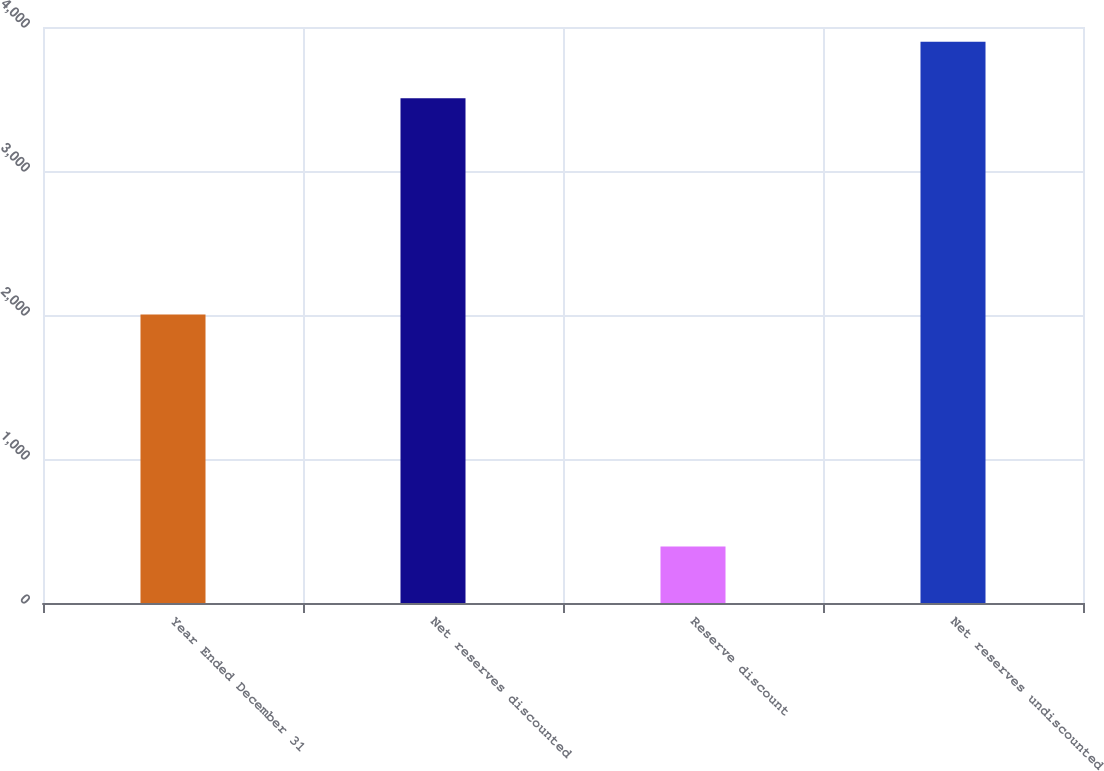Convert chart. <chart><loc_0><loc_0><loc_500><loc_500><bar_chart><fcel>Year Ended December 31<fcel>Net reserves discounted<fcel>Reserve discount<fcel>Net reserves undiscounted<nl><fcel>2003<fcel>3505<fcel>393<fcel>3898<nl></chart> 